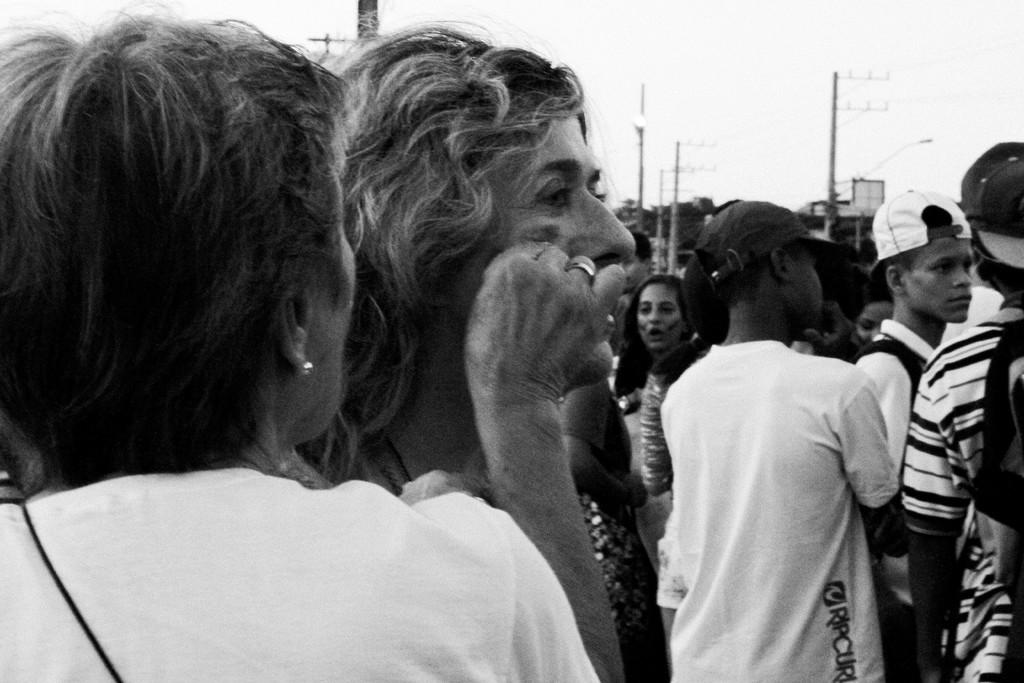What is the color scheme of the image? The image is black and white. What can be seen in the image besides the color scheme? There are groups of people standing in the image, as well as poles. What type of structure might be depicted in the image? The image appears to depict a building. How much grain is being stored in the building in the image? There is no indication of grain storage in the image, as it primarily features groups of people and poles. What type of salt can be seen on the poles in the image? There is no salt present on the poles in the image; they are simply poles. 